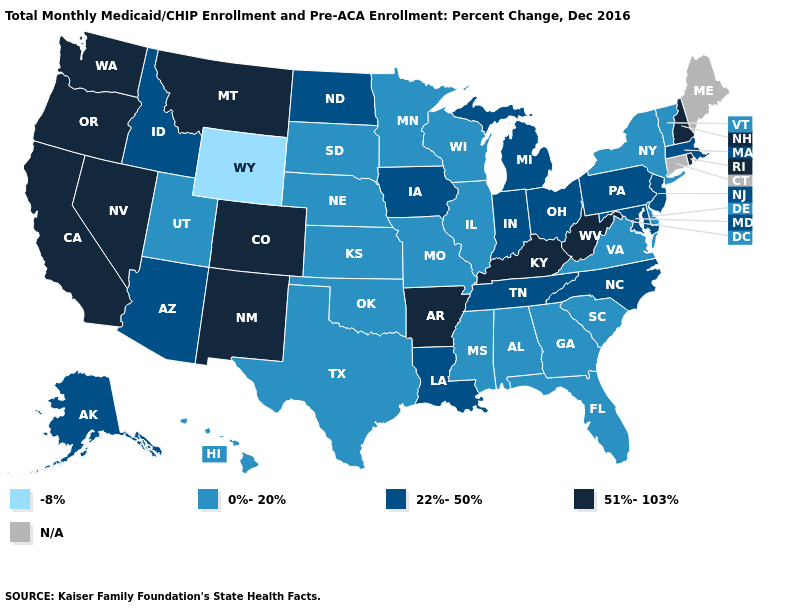Name the states that have a value in the range 51%-103%?
Give a very brief answer. Arkansas, California, Colorado, Kentucky, Montana, Nevada, New Hampshire, New Mexico, Oregon, Rhode Island, Washington, West Virginia. What is the highest value in the South ?
Concise answer only. 51%-103%. What is the lowest value in the Northeast?
Short answer required. 0%-20%. What is the value of Colorado?
Write a very short answer. 51%-103%. What is the lowest value in states that border Maine?
Keep it brief. 51%-103%. Among the states that border Michigan , does Indiana have the lowest value?
Keep it brief. No. Does Indiana have the lowest value in the USA?
Be succinct. No. Does the map have missing data?
Short answer required. Yes. What is the highest value in the South ?
Short answer required. 51%-103%. Name the states that have a value in the range 22%-50%?
Keep it brief. Alaska, Arizona, Idaho, Indiana, Iowa, Louisiana, Maryland, Massachusetts, Michigan, New Jersey, North Carolina, North Dakota, Ohio, Pennsylvania, Tennessee. What is the value of Texas?
Quick response, please. 0%-20%. Which states hav the highest value in the South?
Keep it brief. Arkansas, Kentucky, West Virginia. Does the map have missing data?
Short answer required. Yes. What is the lowest value in the USA?
Be succinct. -8%. 